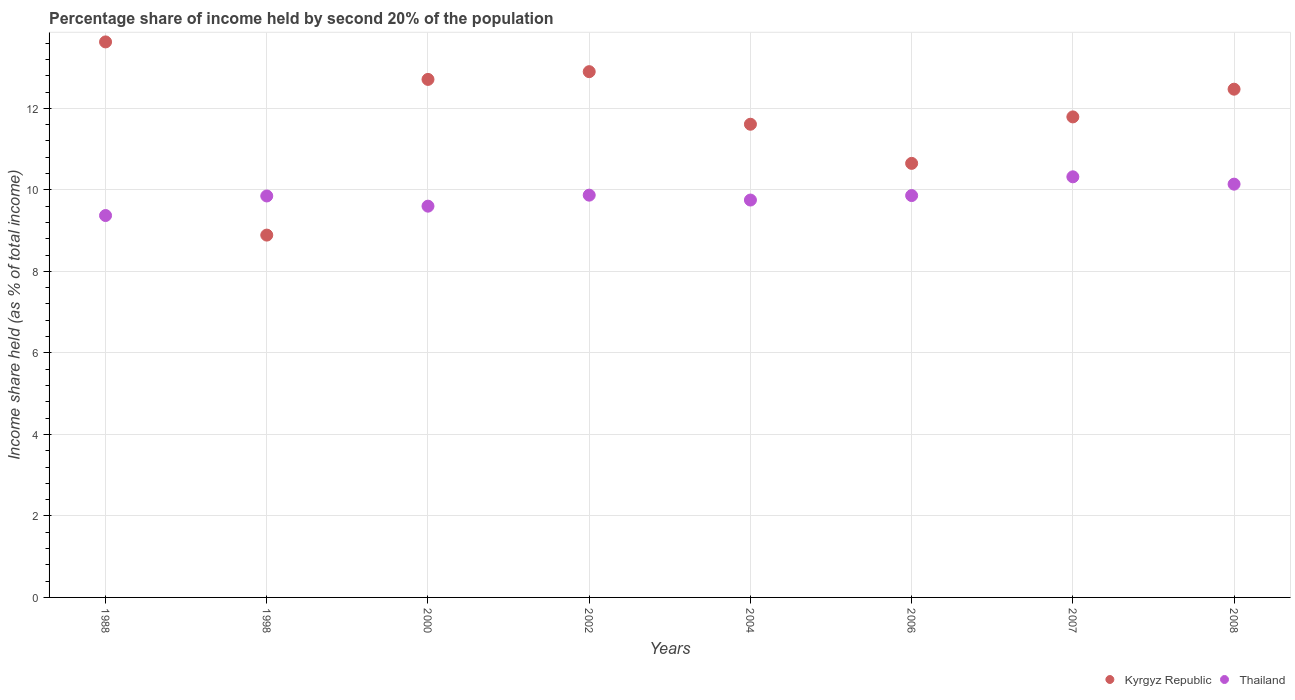How many different coloured dotlines are there?
Give a very brief answer. 2. Is the number of dotlines equal to the number of legend labels?
Offer a terse response. Yes. Across all years, what is the maximum share of income held by second 20% of the population in Kyrgyz Republic?
Offer a terse response. 13.63. Across all years, what is the minimum share of income held by second 20% of the population in Kyrgyz Republic?
Make the answer very short. 8.89. In which year was the share of income held by second 20% of the population in Kyrgyz Republic maximum?
Keep it short and to the point. 1988. What is the total share of income held by second 20% of the population in Kyrgyz Republic in the graph?
Your answer should be very brief. 94.65. What is the difference between the share of income held by second 20% of the population in Kyrgyz Republic in 1988 and that in 2006?
Ensure brevity in your answer.  2.98. What is the difference between the share of income held by second 20% of the population in Thailand in 2002 and the share of income held by second 20% of the population in Kyrgyz Republic in 2007?
Ensure brevity in your answer.  -1.92. What is the average share of income held by second 20% of the population in Thailand per year?
Provide a short and direct response. 9.84. In the year 2002, what is the difference between the share of income held by second 20% of the population in Kyrgyz Republic and share of income held by second 20% of the population in Thailand?
Your answer should be very brief. 3.03. In how many years, is the share of income held by second 20% of the population in Kyrgyz Republic greater than 6 %?
Ensure brevity in your answer.  8. What is the ratio of the share of income held by second 20% of the population in Thailand in 2000 to that in 2006?
Provide a succinct answer. 0.97. Is the difference between the share of income held by second 20% of the population in Kyrgyz Republic in 1988 and 2008 greater than the difference between the share of income held by second 20% of the population in Thailand in 1988 and 2008?
Give a very brief answer. Yes. What is the difference between the highest and the second highest share of income held by second 20% of the population in Thailand?
Keep it short and to the point. 0.18. What is the difference between the highest and the lowest share of income held by second 20% of the population in Thailand?
Make the answer very short. 0.95. In how many years, is the share of income held by second 20% of the population in Kyrgyz Republic greater than the average share of income held by second 20% of the population in Kyrgyz Republic taken over all years?
Give a very brief answer. 4. Does the share of income held by second 20% of the population in Kyrgyz Republic monotonically increase over the years?
Offer a terse response. No. Is the share of income held by second 20% of the population in Thailand strictly less than the share of income held by second 20% of the population in Kyrgyz Republic over the years?
Provide a short and direct response. No. How many dotlines are there?
Provide a succinct answer. 2. How many years are there in the graph?
Offer a very short reply. 8. What is the difference between two consecutive major ticks on the Y-axis?
Keep it short and to the point. 2. Are the values on the major ticks of Y-axis written in scientific E-notation?
Provide a succinct answer. No. Does the graph contain any zero values?
Ensure brevity in your answer.  No. Where does the legend appear in the graph?
Give a very brief answer. Bottom right. How are the legend labels stacked?
Give a very brief answer. Horizontal. What is the title of the graph?
Keep it short and to the point. Percentage share of income held by second 20% of the population. What is the label or title of the X-axis?
Provide a succinct answer. Years. What is the label or title of the Y-axis?
Provide a short and direct response. Income share held (as % of total income). What is the Income share held (as % of total income) of Kyrgyz Republic in 1988?
Make the answer very short. 13.63. What is the Income share held (as % of total income) in Thailand in 1988?
Provide a short and direct response. 9.37. What is the Income share held (as % of total income) in Kyrgyz Republic in 1998?
Your response must be concise. 8.89. What is the Income share held (as % of total income) in Thailand in 1998?
Provide a succinct answer. 9.85. What is the Income share held (as % of total income) in Kyrgyz Republic in 2000?
Offer a terse response. 12.71. What is the Income share held (as % of total income) in Thailand in 2002?
Ensure brevity in your answer.  9.87. What is the Income share held (as % of total income) of Kyrgyz Republic in 2004?
Provide a short and direct response. 11.61. What is the Income share held (as % of total income) of Thailand in 2004?
Offer a very short reply. 9.75. What is the Income share held (as % of total income) of Kyrgyz Republic in 2006?
Give a very brief answer. 10.65. What is the Income share held (as % of total income) in Thailand in 2006?
Keep it short and to the point. 9.86. What is the Income share held (as % of total income) of Kyrgyz Republic in 2007?
Your answer should be compact. 11.79. What is the Income share held (as % of total income) in Thailand in 2007?
Ensure brevity in your answer.  10.32. What is the Income share held (as % of total income) in Kyrgyz Republic in 2008?
Ensure brevity in your answer.  12.47. What is the Income share held (as % of total income) in Thailand in 2008?
Keep it short and to the point. 10.14. Across all years, what is the maximum Income share held (as % of total income) of Kyrgyz Republic?
Your answer should be compact. 13.63. Across all years, what is the maximum Income share held (as % of total income) in Thailand?
Offer a terse response. 10.32. Across all years, what is the minimum Income share held (as % of total income) of Kyrgyz Republic?
Your response must be concise. 8.89. Across all years, what is the minimum Income share held (as % of total income) of Thailand?
Your answer should be very brief. 9.37. What is the total Income share held (as % of total income) in Kyrgyz Republic in the graph?
Keep it short and to the point. 94.65. What is the total Income share held (as % of total income) in Thailand in the graph?
Keep it short and to the point. 78.76. What is the difference between the Income share held (as % of total income) of Kyrgyz Republic in 1988 and that in 1998?
Provide a succinct answer. 4.74. What is the difference between the Income share held (as % of total income) of Thailand in 1988 and that in 1998?
Make the answer very short. -0.48. What is the difference between the Income share held (as % of total income) of Thailand in 1988 and that in 2000?
Your response must be concise. -0.23. What is the difference between the Income share held (as % of total income) in Kyrgyz Republic in 1988 and that in 2002?
Give a very brief answer. 0.73. What is the difference between the Income share held (as % of total income) in Thailand in 1988 and that in 2002?
Keep it short and to the point. -0.5. What is the difference between the Income share held (as % of total income) of Kyrgyz Republic in 1988 and that in 2004?
Make the answer very short. 2.02. What is the difference between the Income share held (as % of total income) of Thailand in 1988 and that in 2004?
Give a very brief answer. -0.38. What is the difference between the Income share held (as % of total income) in Kyrgyz Republic in 1988 and that in 2006?
Your answer should be compact. 2.98. What is the difference between the Income share held (as % of total income) of Thailand in 1988 and that in 2006?
Your response must be concise. -0.49. What is the difference between the Income share held (as % of total income) of Kyrgyz Republic in 1988 and that in 2007?
Make the answer very short. 1.84. What is the difference between the Income share held (as % of total income) of Thailand in 1988 and that in 2007?
Offer a terse response. -0.95. What is the difference between the Income share held (as % of total income) of Kyrgyz Republic in 1988 and that in 2008?
Ensure brevity in your answer.  1.16. What is the difference between the Income share held (as % of total income) of Thailand in 1988 and that in 2008?
Offer a terse response. -0.77. What is the difference between the Income share held (as % of total income) of Kyrgyz Republic in 1998 and that in 2000?
Offer a terse response. -3.82. What is the difference between the Income share held (as % of total income) in Thailand in 1998 and that in 2000?
Your answer should be compact. 0.25. What is the difference between the Income share held (as % of total income) in Kyrgyz Republic in 1998 and that in 2002?
Offer a very short reply. -4.01. What is the difference between the Income share held (as % of total income) in Thailand in 1998 and that in 2002?
Offer a terse response. -0.02. What is the difference between the Income share held (as % of total income) of Kyrgyz Republic in 1998 and that in 2004?
Your response must be concise. -2.72. What is the difference between the Income share held (as % of total income) in Kyrgyz Republic in 1998 and that in 2006?
Offer a terse response. -1.76. What is the difference between the Income share held (as % of total income) in Thailand in 1998 and that in 2006?
Keep it short and to the point. -0.01. What is the difference between the Income share held (as % of total income) of Kyrgyz Republic in 1998 and that in 2007?
Keep it short and to the point. -2.9. What is the difference between the Income share held (as % of total income) in Thailand in 1998 and that in 2007?
Provide a succinct answer. -0.47. What is the difference between the Income share held (as % of total income) of Kyrgyz Republic in 1998 and that in 2008?
Offer a very short reply. -3.58. What is the difference between the Income share held (as % of total income) of Thailand in 1998 and that in 2008?
Provide a succinct answer. -0.29. What is the difference between the Income share held (as % of total income) in Kyrgyz Republic in 2000 and that in 2002?
Offer a terse response. -0.19. What is the difference between the Income share held (as % of total income) in Thailand in 2000 and that in 2002?
Provide a short and direct response. -0.27. What is the difference between the Income share held (as % of total income) in Kyrgyz Republic in 2000 and that in 2004?
Your response must be concise. 1.1. What is the difference between the Income share held (as % of total income) in Kyrgyz Republic in 2000 and that in 2006?
Your response must be concise. 2.06. What is the difference between the Income share held (as % of total income) of Thailand in 2000 and that in 2006?
Make the answer very short. -0.26. What is the difference between the Income share held (as % of total income) in Thailand in 2000 and that in 2007?
Make the answer very short. -0.72. What is the difference between the Income share held (as % of total income) of Kyrgyz Republic in 2000 and that in 2008?
Ensure brevity in your answer.  0.24. What is the difference between the Income share held (as % of total income) of Thailand in 2000 and that in 2008?
Provide a short and direct response. -0.54. What is the difference between the Income share held (as % of total income) of Kyrgyz Republic in 2002 and that in 2004?
Make the answer very short. 1.29. What is the difference between the Income share held (as % of total income) in Thailand in 2002 and that in 2004?
Offer a terse response. 0.12. What is the difference between the Income share held (as % of total income) in Kyrgyz Republic in 2002 and that in 2006?
Offer a terse response. 2.25. What is the difference between the Income share held (as % of total income) in Kyrgyz Republic in 2002 and that in 2007?
Give a very brief answer. 1.11. What is the difference between the Income share held (as % of total income) of Thailand in 2002 and that in 2007?
Your answer should be very brief. -0.45. What is the difference between the Income share held (as % of total income) in Kyrgyz Republic in 2002 and that in 2008?
Your answer should be compact. 0.43. What is the difference between the Income share held (as % of total income) in Thailand in 2002 and that in 2008?
Provide a short and direct response. -0.27. What is the difference between the Income share held (as % of total income) in Kyrgyz Republic in 2004 and that in 2006?
Your answer should be very brief. 0.96. What is the difference between the Income share held (as % of total income) of Thailand in 2004 and that in 2006?
Ensure brevity in your answer.  -0.11. What is the difference between the Income share held (as % of total income) of Kyrgyz Republic in 2004 and that in 2007?
Provide a short and direct response. -0.18. What is the difference between the Income share held (as % of total income) of Thailand in 2004 and that in 2007?
Give a very brief answer. -0.57. What is the difference between the Income share held (as % of total income) in Kyrgyz Republic in 2004 and that in 2008?
Provide a short and direct response. -0.86. What is the difference between the Income share held (as % of total income) of Thailand in 2004 and that in 2008?
Your response must be concise. -0.39. What is the difference between the Income share held (as % of total income) in Kyrgyz Republic in 2006 and that in 2007?
Ensure brevity in your answer.  -1.14. What is the difference between the Income share held (as % of total income) of Thailand in 2006 and that in 2007?
Make the answer very short. -0.46. What is the difference between the Income share held (as % of total income) of Kyrgyz Republic in 2006 and that in 2008?
Your answer should be very brief. -1.82. What is the difference between the Income share held (as % of total income) of Thailand in 2006 and that in 2008?
Your answer should be compact. -0.28. What is the difference between the Income share held (as % of total income) in Kyrgyz Republic in 2007 and that in 2008?
Ensure brevity in your answer.  -0.68. What is the difference between the Income share held (as % of total income) in Thailand in 2007 and that in 2008?
Offer a terse response. 0.18. What is the difference between the Income share held (as % of total income) in Kyrgyz Republic in 1988 and the Income share held (as % of total income) in Thailand in 1998?
Ensure brevity in your answer.  3.78. What is the difference between the Income share held (as % of total income) of Kyrgyz Republic in 1988 and the Income share held (as % of total income) of Thailand in 2000?
Keep it short and to the point. 4.03. What is the difference between the Income share held (as % of total income) of Kyrgyz Republic in 1988 and the Income share held (as % of total income) of Thailand in 2002?
Ensure brevity in your answer.  3.76. What is the difference between the Income share held (as % of total income) of Kyrgyz Republic in 1988 and the Income share held (as % of total income) of Thailand in 2004?
Provide a short and direct response. 3.88. What is the difference between the Income share held (as % of total income) of Kyrgyz Republic in 1988 and the Income share held (as % of total income) of Thailand in 2006?
Your response must be concise. 3.77. What is the difference between the Income share held (as % of total income) in Kyrgyz Republic in 1988 and the Income share held (as % of total income) in Thailand in 2007?
Your response must be concise. 3.31. What is the difference between the Income share held (as % of total income) of Kyrgyz Republic in 1988 and the Income share held (as % of total income) of Thailand in 2008?
Ensure brevity in your answer.  3.49. What is the difference between the Income share held (as % of total income) of Kyrgyz Republic in 1998 and the Income share held (as % of total income) of Thailand in 2000?
Ensure brevity in your answer.  -0.71. What is the difference between the Income share held (as % of total income) in Kyrgyz Republic in 1998 and the Income share held (as % of total income) in Thailand in 2002?
Offer a very short reply. -0.98. What is the difference between the Income share held (as % of total income) of Kyrgyz Republic in 1998 and the Income share held (as % of total income) of Thailand in 2004?
Offer a very short reply. -0.86. What is the difference between the Income share held (as % of total income) of Kyrgyz Republic in 1998 and the Income share held (as % of total income) of Thailand in 2006?
Your answer should be very brief. -0.97. What is the difference between the Income share held (as % of total income) in Kyrgyz Republic in 1998 and the Income share held (as % of total income) in Thailand in 2007?
Make the answer very short. -1.43. What is the difference between the Income share held (as % of total income) of Kyrgyz Republic in 1998 and the Income share held (as % of total income) of Thailand in 2008?
Make the answer very short. -1.25. What is the difference between the Income share held (as % of total income) in Kyrgyz Republic in 2000 and the Income share held (as % of total income) in Thailand in 2002?
Provide a short and direct response. 2.84. What is the difference between the Income share held (as % of total income) of Kyrgyz Republic in 2000 and the Income share held (as % of total income) of Thailand in 2004?
Give a very brief answer. 2.96. What is the difference between the Income share held (as % of total income) in Kyrgyz Republic in 2000 and the Income share held (as % of total income) in Thailand in 2006?
Give a very brief answer. 2.85. What is the difference between the Income share held (as % of total income) of Kyrgyz Republic in 2000 and the Income share held (as % of total income) of Thailand in 2007?
Offer a terse response. 2.39. What is the difference between the Income share held (as % of total income) in Kyrgyz Republic in 2000 and the Income share held (as % of total income) in Thailand in 2008?
Provide a succinct answer. 2.57. What is the difference between the Income share held (as % of total income) in Kyrgyz Republic in 2002 and the Income share held (as % of total income) in Thailand in 2004?
Provide a short and direct response. 3.15. What is the difference between the Income share held (as % of total income) in Kyrgyz Republic in 2002 and the Income share held (as % of total income) in Thailand in 2006?
Offer a terse response. 3.04. What is the difference between the Income share held (as % of total income) in Kyrgyz Republic in 2002 and the Income share held (as % of total income) in Thailand in 2007?
Your answer should be very brief. 2.58. What is the difference between the Income share held (as % of total income) in Kyrgyz Republic in 2002 and the Income share held (as % of total income) in Thailand in 2008?
Your response must be concise. 2.76. What is the difference between the Income share held (as % of total income) in Kyrgyz Republic in 2004 and the Income share held (as % of total income) in Thailand in 2006?
Ensure brevity in your answer.  1.75. What is the difference between the Income share held (as % of total income) of Kyrgyz Republic in 2004 and the Income share held (as % of total income) of Thailand in 2007?
Provide a short and direct response. 1.29. What is the difference between the Income share held (as % of total income) in Kyrgyz Republic in 2004 and the Income share held (as % of total income) in Thailand in 2008?
Offer a terse response. 1.47. What is the difference between the Income share held (as % of total income) in Kyrgyz Republic in 2006 and the Income share held (as % of total income) in Thailand in 2007?
Your response must be concise. 0.33. What is the difference between the Income share held (as % of total income) of Kyrgyz Republic in 2006 and the Income share held (as % of total income) of Thailand in 2008?
Offer a very short reply. 0.51. What is the difference between the Income share held (as % of total income) in Kyrgyz Republic in 2007 and the Income share held (as % of total income) in Thailand in 2008?
Provide a short and direct response. 1.65. What is the average Income share held (as % of total income) of Kyrgyz Republic per year?
Your response must be concise. 11.83. What is the average Income share held (as % of total income) of Thailand per year?
Your answer should be very brief. 9.85. In the year 1988, what is the difference between the Income share held (as % of total income) of Kyrgyz Republic and Income share held (as % of total income) of Thailand?
Make the answer very short. 4.26. In the year 1998, what is the difference between the Income share held (as % of total income) in Kyrgyz Republic and Income share held (as % of total income) in Thailand?
Your answer should be very brief. -0.96. In the year 2000, what is the difference between the Income share held (as % of total income) of Kyrgyz Republic and Income share held (as % of total income) of Thailand?
Offer a terse response. 3.11. In the year 2002, what is the difference between the Income share held (as % of total income) of Kyrgyz Republic and Income share held (as % of total income) of Thailand?
Make the answer very short. 3.03. In the year 2004, what is the difference between the Income share held (as % of total income) of Kyrgyz Republic and Income share held (as % of total income) of Thailand?
Make the answer very short. 1.86. In the year 2006, what is the difference between the Income share held (as % of total income) of Kyrgyz Republic and Income share held (as % of total income) of Thailand?
Your answer should be very brief. 0.79. In the year 2007, what is the difference between the Income share held (as % of total income) of Kyrgyz Republic and Income share held (as % of total income) of Thailand?
Your answer should be compact. 1.47. In the year 2008, what is the difference between the Income share held (as % of total income) of Kyrgyz Republic and Income share held (as % of total income) of Thailand?
Your answer should be very brief. 2.33. What is the ratio of the Income share held (as % of total income) of Kyrgyz Republic in 1988 to that in 1998?
Make the answer very short. 1.53. What is the ratio of the Income share held (as % of total income) in Thailand in 1988 to that in 1998?
Provide a short and direct response. 0.95. What is the ratio of the Income share held (as % of total income) in Kyrgyz Republic in 1988 to that in 2000?
Ensure brevity in your answer.  1.07. What is the ratio of the Income share held (as % of total income) of Kyrgyz Republic in 1988 to that in 2002?
Offer a very short reply. 1.06. What is the ratio of the Income share held (as % of total income) in Thailand in 1988 to that in 2002?
Keep it short and to the point. 0.95. What is the ratio of the Income share held (as % of total income) of Kyrgyz Republic in 1988 to that in 2004?
Provide a short and direct response. 1.17. What is the ratio of the Income share held (as % of total income) of Kyrgyz Republic in 1988 to that in 2006?
Ensure brevity in your answer.  1.28. What is the ratio of the Income share held (as % of total income) of Thailand in 1988 to that in 2006?
Your answer should be compact. 0.95. What is the ratio of the Income share held (as % of total income) of Kyrgyz Republic in 1988 to that in 2007?
Your answer should be compact. 1.16. What is the ratio of the Income share held (as % of total income) in Thailand in 1988 to that in 2007?
Give a very brief answer. 0.91. What is the ratio of the Income share held (as % of total income) of Kyrgyz Republic in 1988 to that in 2008?
Your response must be concise. 1.09. What is the ratio of the Income share held (as % of total income) of Thailand in 1988 to that in 2008?
Offer a very short reply. 0.92. What is the ratio of the Income share held (as % of total income) of Kyrgyz Republic in 1998 to that in 2000?
Your response must be concise. 0.7. What is the ratio of the Income share held (as % of total income) in Thailand in 1998 to that in 2000?
Your response must be concise. 1.03. What is the ratio of the Income share held (as % of total income) in Kyrgyz Republic in 1998 to that in 2002?
Offer a terse response. 0.69. What is the ratio of the Income share held (as % of total income) in Thailand in 1998 to that in 2002?
Your answer should be compact. 1. What is the ratio of the Income share held (as % of total income) in Kyrgyz Republic in 1998 to that in 2004?
Your answer should be very brief. 0.77. What is the ratio of the Income share held (as % of total income) of Thailand in 1998 to that in 2004?
Your answer should be compact. 1.01. What is the ratio of the Income share held (as % of total income) of Kyrgyz Republic in 1998 to that in 2006?
Provide a succinct answer. 0.83. What is the ratio of the Income share held (as % of total income) in Kyrgyz Republic in 1998 to that in 2007?
Your answer should be compact. 0.75. What is the ratio of the Income share held (as % of total income) of Thailand in 1998 to that in 2007?
Provide a short and direct response. 0.95. What is the ratio of the Income share held (as % of total income) in Kyrgyz Republic in 1998 to that in 2008?
Ensure brevity in your answer.  0.71. What is the ratio of the Income share held (as % of total income) in Thailand in 1998 to that in 2008?
Offer a very short reply. 0.97. What is the ratio of the Income share held (as % of total income) of Kyrgyz Republic in 2000 to that in 2002?
Offer a very short reply. 0.99. What is the ratio of the Income share held (as % of total income) in Thailand in 2000 to that in 2002?
Your answer should be very brief. 0.97. What is the ratio of the Income share held (as % of total income) of Kyrgyz Republic in 2000 to that in 2004?
Your answer should be compact. 1.09. What is the ratio of the Income share held (as % of total income) of Thailand in 2000 to that in 2004?
Make the answer very short. 0.98. What is the ratio of the Income share held (as % of total income) in Kyrgyz Republic in 2000 to that in 2006?
Your response must be concise. 1.19. What is the ratio of the Income share held (as % of total income) in Thailand in 2000 to that in 2006?
Your answer should be compact. 0.97. What is the ratio of the Income share held (as % of total income) in Kyrgyz Republic in 2000 to that in 2007?
Your response must be concise. 1.08. What is the ratio of the Income share held (as % of total income) in Thailand in 2000 to that in 2007?
Offer a terse response. 0.93. What is the ratio of the Income share held (as % of total income) of Kyrgyz Republic in 2000 to that in 2008?
Your response must be concise. 1.02. What is the ratio of the Income share held (as % of total income) in Thailand in 2000 to that in 2008?
Your answer should be very brief. 0.95. What is the ratio of the Income share held (as % of total income) in Kyrgyz Republic in 2002 to that in 2004?
Your response must be concise. 1.11. What is the ratio of the Income share held (as % of total income) of Thailand in 2002 to that in 2004?
Offer a very short reply. 1.01. What is the ratio of the Income share held (as % of total income) of Kyrgyz Republic in 2002 to that in 2006?
Ensure brevity in your answer.  1.21. What is the ratio of the Income share held (as % of total income) in Kyrgyz Republic in 2002 to that in 2007?
Your answer should be very brief. 1.09. What is the ratio of the Income share held (as % of total income) of Thailand in 2002 to that in 2007?
Keep it short and to the point. 0.96. What is the ratio of the Income share held (as % of total income) in Kyrgyz Republic in 2002 to that in 2008?
Your answer should be very brief. 1.03. What is the ratio of the Income share held (as % of total income) in Thailand in 2002 to that in 2008?
Provide a short and direct response. 0.97. What is the ratio of the Income share held (as % of total income) of Kyrgyz Republic in 2004 to that in 2006?
Your answer should be compact. 1.09. What is the ratio of the Income share held (as % of total income) in Kyrgyz Republic in 2004 to that in 2007?
Keep it short and to the point. 0.98. What is the ratio of the Income share held (as % of total income) of Thailand in 2004 to that in 2007?
Your answer should be very brief. 0.94. What is the ratio of the Income share held (as % of total income) of Kyrgyz Republic in 2004 to that in 2008?
Offer a very short reply. 0.93. What is the ratio of the Income share held (as % of total income) of Thailand in 2004 to that in 2008?
Provide a succinct answer. 0.96. What is the ratio of the Income share held (as % of total income) of Kyrgyz Republic in 2006 to that in 2007?
Your answer should be very brief. 0.9. What is the ratio of the Income share held (as % of total income) in Thailand in 2006 to that in 2007?
Your response must be concise. 0.96. What is the ratio of the Income share held (as % of total income) of Kyrgyz Republic in 2006 to that in 2008?
Offer a terse response. 0.85. What is the ratio of the Income share held (as % of total income) in Thailand in 2006 to that in 2008?
Offer a terse response. 0.97. What is the ratio of the Income share held (as % of total income) of Kyrgyz Republic in 2007 to that in 2008?
Offer a very short reply. 0.95. What is the ratio of the Income share held (as % of total income) of Thailand in 2007 to that in 2008?
Offer a very short reply. 1.02. What is the difference between the highest and the second highest Income share held (as % of total income) of Kyrgyz Republic?
Give a very brief answer. 0.73. What is the difference between the highest and the second highest Income share held (as % of total income) in Thailand?
Your answer should be compact. 0.18. What is the difference between the highest and the lowest Income share held (as % of total income) of Kyrgyz Republic?
Your response must be concise. 4.74. 